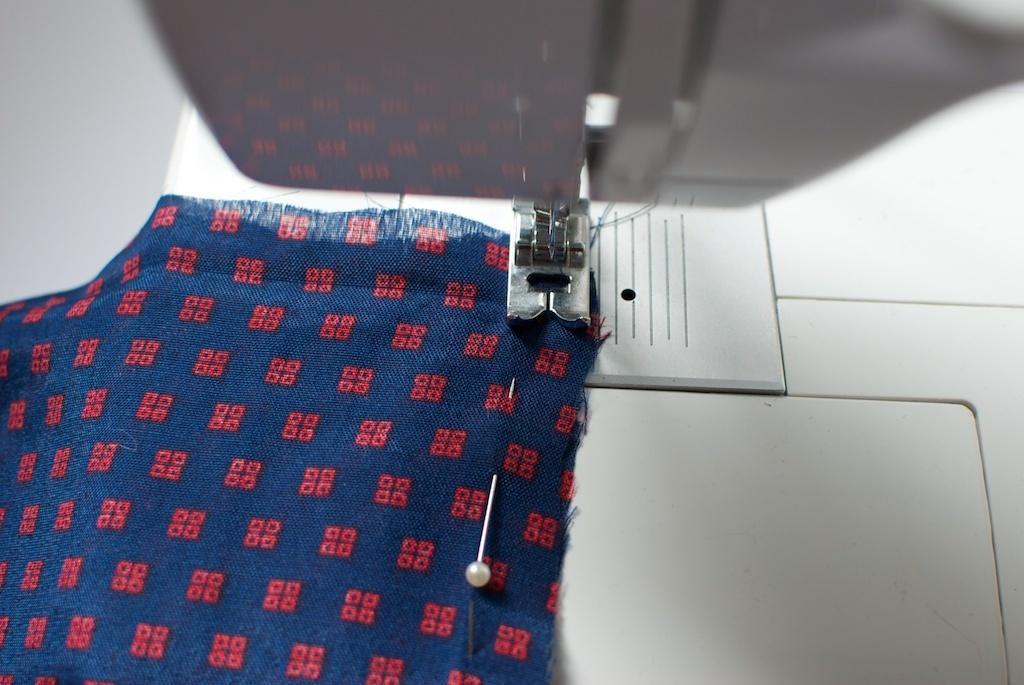Could you give a brief overview of what you see in this image? In the foreground of this image, there is a sewing machine on which there is a cloth and we can see a pin to the cloth. 